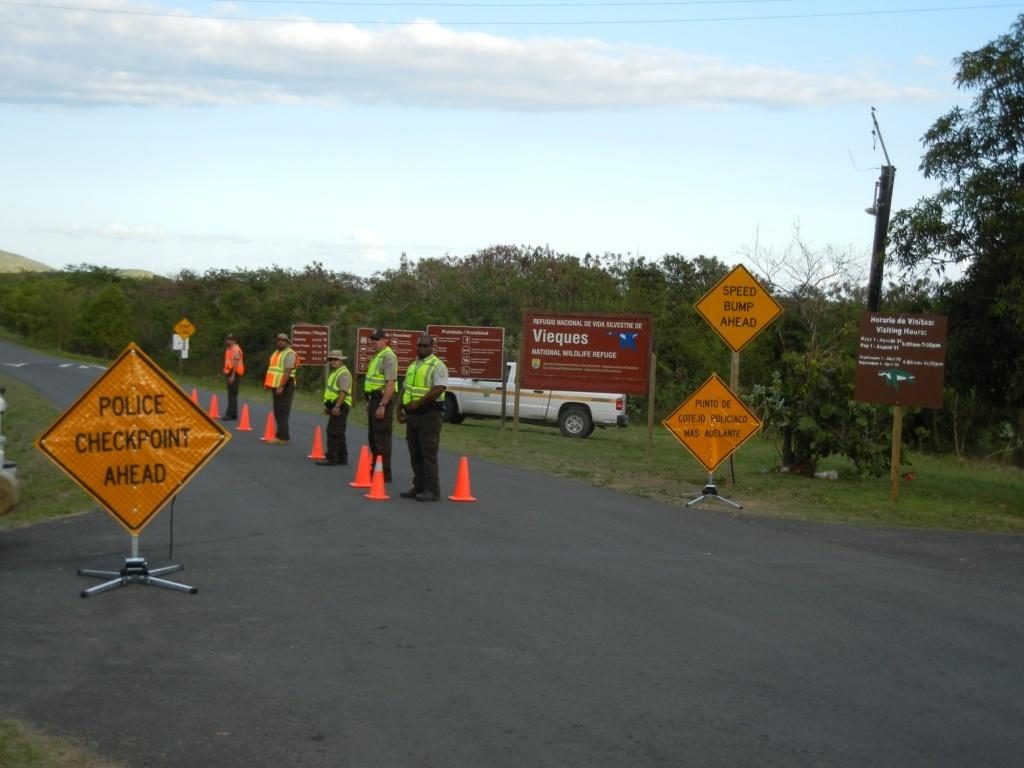<image>
Give a short and clear explanation of the subsequent image. A police checkpoint sign is next to said police checkpoint, at the Vieques National Wildlife Refuge. 